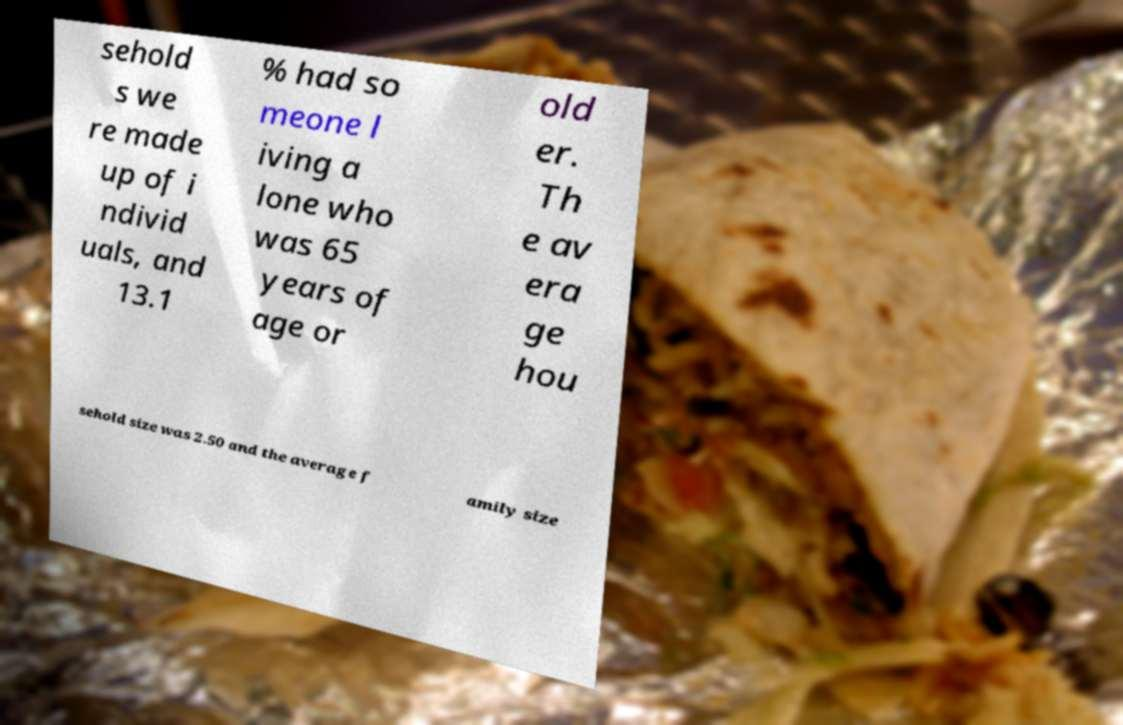I need the written content from this picture converted into text. Can you do that? sehold s we re made up of i ndivid uals, and 13.1 % had so meone l iving a lone who was 65 years of age or old er. Th e av era ge hou sehold size was 2.50 and the average f amily size 